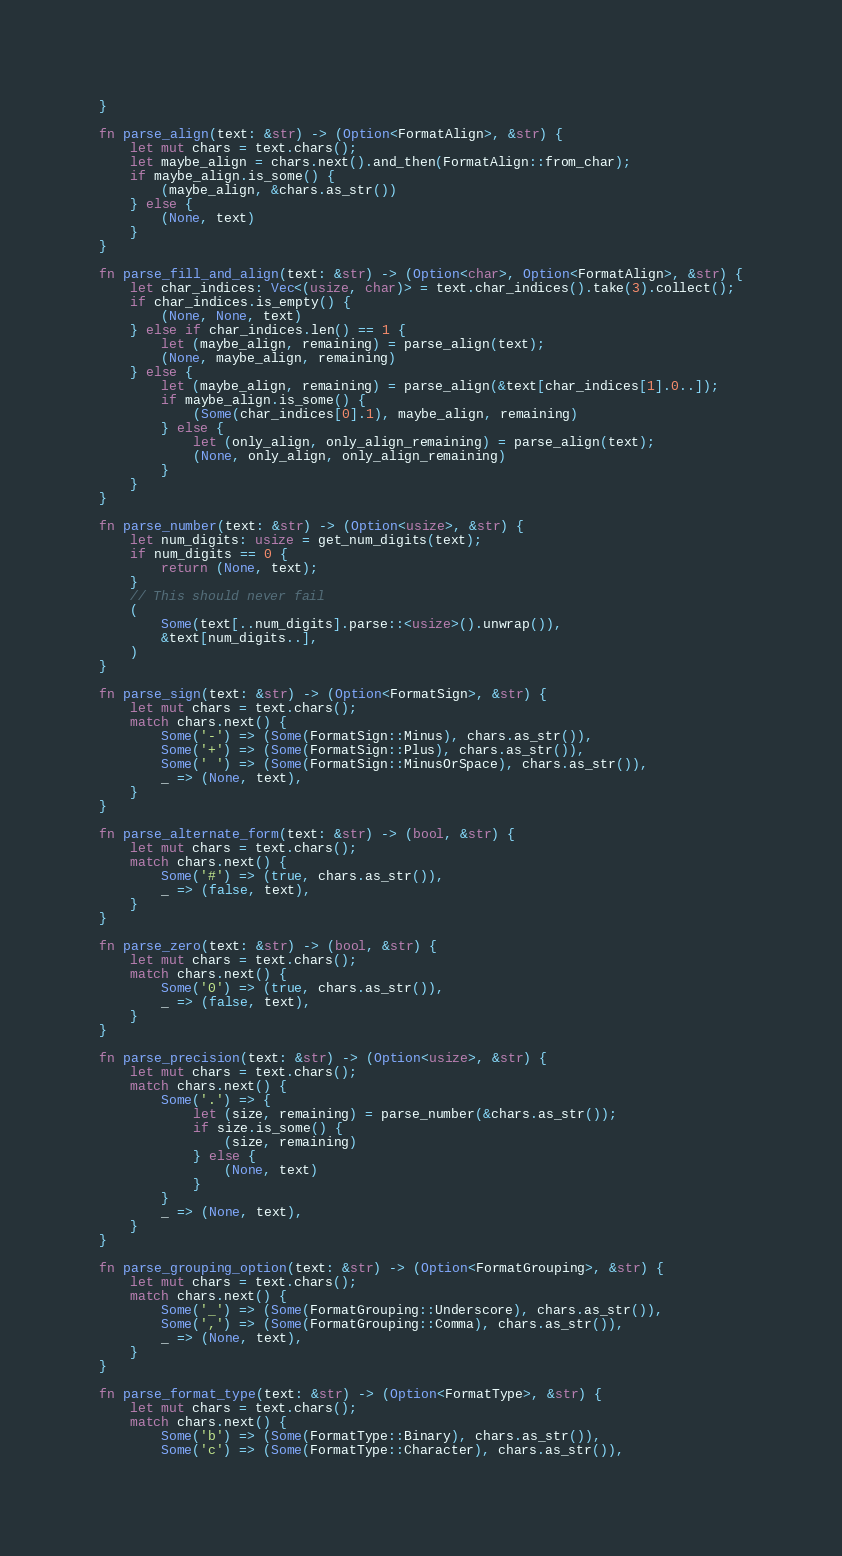Convert code to text. <code><loc_0><loc_0><loc_500><loc_500><_Rust_>}

fn parse_align(text: &str) -> (Option<FormatAlign>, &str) {
    let mut chars = text.chars();
    let maybe_align = chars.next().and_then(FormatAlign::from_char);
    if maybe_align.is_some() {
        (maybe_align, &chars.as_str())
    } else {
        (None, text)
    }
}

fn parse_fill_and_align(text: &str) -> (Option<char>, Option<FormatAlign>, &str) {
    let char_indices: Vec<(usize, char)> = text.char_indices().take(3).collect();
    if char_indices.is_empty() {
        (None, None, text)
    } else if char_indices.len() == 1 {
        let (maybe_align, remaining) = parse_align(text);
        (None, maybe_align, remaining)
    } else {
        let (maybe_align, remaining) = parse_align(&text[char_indices[1].0..]);
        if maybe_align.is_some() {
            (Some(char_indices[0].1), maybe_align, remaining)
        } else {
            let (only_align, only_align_remaining) = parse_align(text);
            (None, only_align, only_align_remaining)
        }
    }
}

fn parse_number(text: &str) -> (Option<usize>, &str) {
    let num_digits: usize = get_num_digits(text);
    if num_digits == 0 {
        return (None, text);
    }
    // This should never fail
    (
        Some(text[..num_digits].parse::<usize>().unwrap()),
        &text[num_digits..],
    )
}

fn parse_sign(text: &str) -> (Option<FormatSign>, &str) {
    let mut chars = text.chars();
    match chars.next() {
        Some('-') => (Some(FormatSign::Minus), chars.as_str()),
        Some('+') => (Some(FormatSign::Plus), chars.as_str()),
        Some(' ') => (Some(FormatSign::MinusOrSpace), chars.as_str()),
        _ => (None, text),
    }
}

fn parse_alternate_form(text: &str) -> (bool, &str) {
    let mut chars = text.chars();
    match chars.next() {
        Some('#') => (true, chars.as_str()),
        _ => (false, text),
    }
}

fn parse_zero(text: &str) -> (bool, &str) {
    let mut chars = text.chars();
    match chars.next() {
        Some('0') => (true, chars.as_str()),
        _ => (false, text),
    }
}

fn parse_precision(text: &str) -> (Option<usize>, &str) {
    let mut chars = text.chars();
    match chars.next() {
        Some('.') => {
            let (size, remaining) = parse_number(&chars.as_str());
            if size.is_some() {
                (size, remaining)
            } else {
                (None, text)
            }
        }
        _ => (None, text),
    }
}

fn parse_grouping_option(text: &str) -> (Option<FormatGrouping>, &str) {
    let mut chars = text.chars();
    match chars.next() {
        Some('_') => (Some(FormatGrouping::Underscore), chars.as_str()),
        Some(',') => (Some(FormatGrouping::Comma), chars.as_str()),
        _ => (None, text),
    }
}

fn parse_format_type(text: &str) -> (Option<FormatType>, &str) {
    let mut chars = text.chars();
    match chars.next() {
        Some('b') => (Some(FormatType::Binary), chars.as_str()),
        Some('c') => (Some(FormatType::Character), chars.as_str()),</code> 